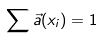<formula> <loc_0><loc_0><loc_500><loc_500>\sum \vec { a } ( x _ { i } ) = 1</formula> 